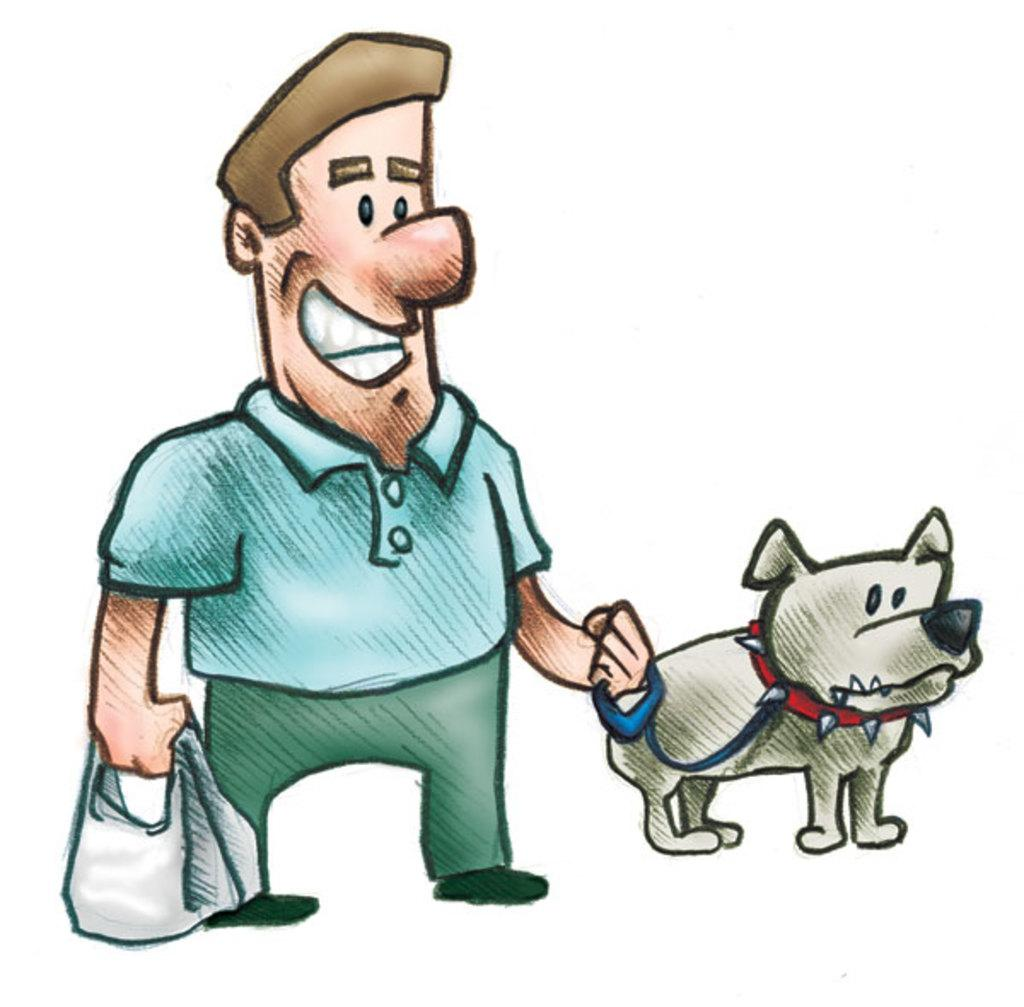What type of character is in the image? The image contains a cartoon man. What is the man holding in the image? The man is holding a bag and a strap. Can you describe the animal in the image? There is a dog on the right side of the image. What is the color of the background in the image? The background of the image is white. What type of clam can be seen laughing in the image? There is no clam present in the image, and clams do not have the ability to laugh. Where is the faucet located in the image? There is no faucet present in the image. 